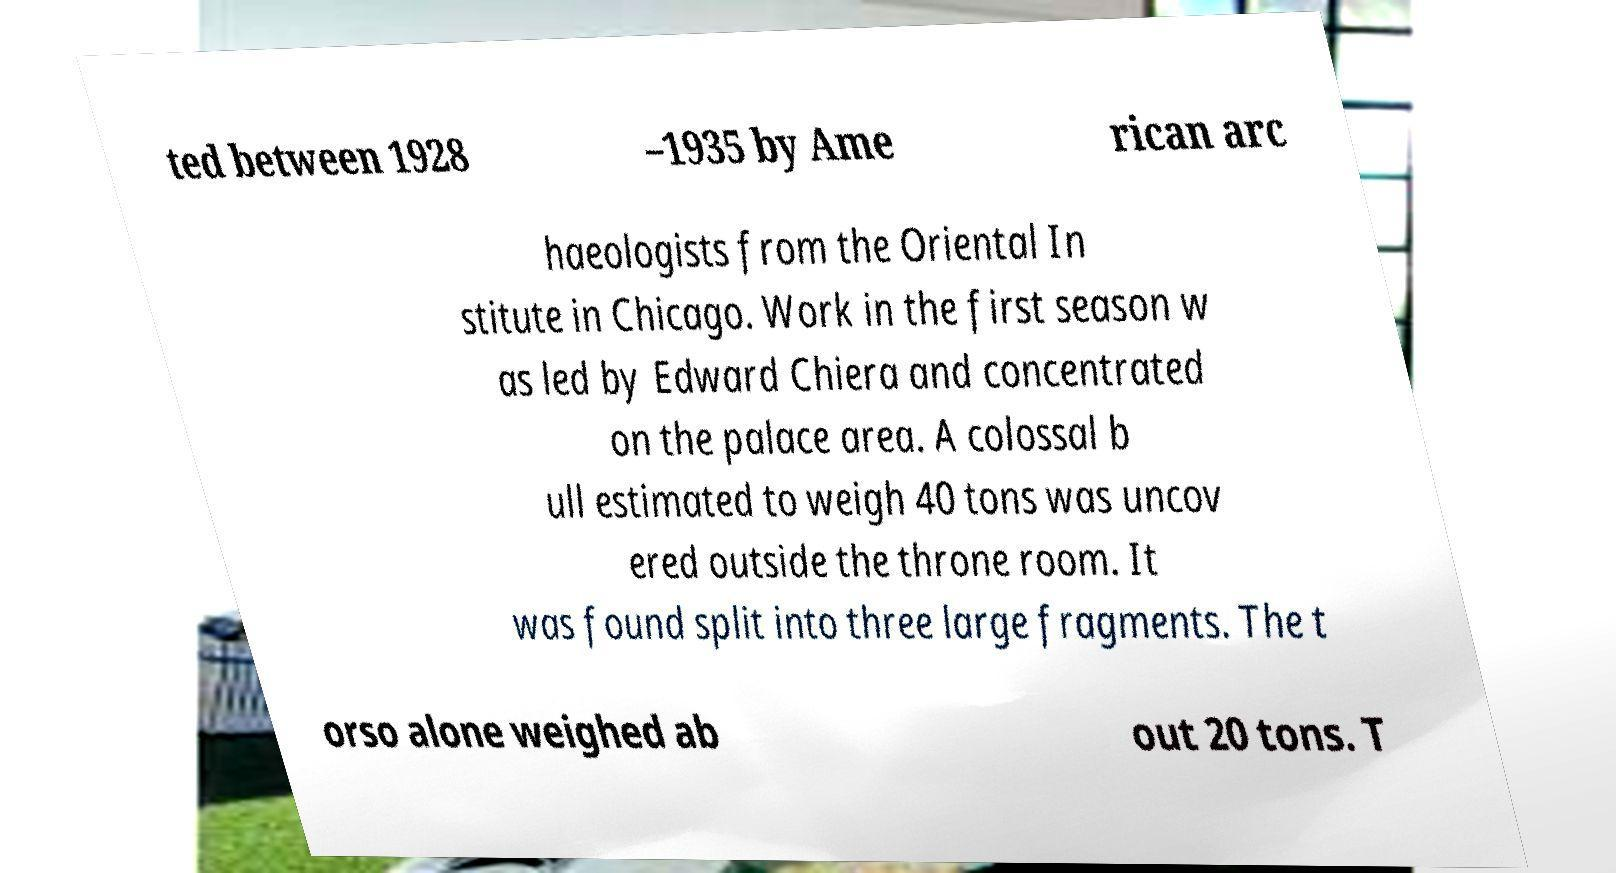Could you assist in decoding the text presented in this image and type it out clearly? ted between 1928 –1935 by Ame rican arc haeologists from the Oriental In stitute in Chicago. Work in the first season w as led by Edward Chiera and concentrated on the palace area. A colossal b ull estimated to weigh 40 tons was uncov ered outside the throne room. It was found split into three large fragments. The t orso alone weighed ab out 20 tons. T 